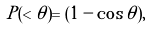<formula> <loc_0><loc_0><loc_500><loc_500>P ( < \theta ) = ( 1 - \cos { \theta } ) ,</formula> 